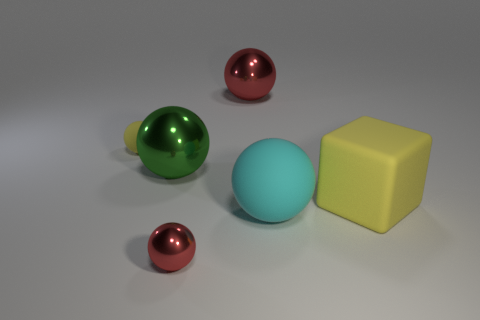The cyan object has what size?
Keep it short and to the point. Large. The big object left of the red sphere in front of the yellow matte thing that is right of the cyan thing is made of what material?
Give a very brief answer. Metal. The big cube that is the same material as the cyan object is what color?
Offer a very short reply. Yellow. How many tiny matte objects are to the right of the yellow object that is in front of the yellow matte object that is to the left of the large yellow rubber block?
Your response must be concise. 0. There is a ball that is the same color as the large block; what material is it?
Offer a very short reply. Rubber. Are there any other things that have the same shape as the large green metal object?
Ensure brevity in your answer.  Yes. How many things are either tiny spheres that are on the right side of the green object or purple metallic balls?
Your response must be concise. 1. Does the big matte object behind the cyan rubber object have the same color as the tiny metallic object?
Offer a terse response. No. The green object in front of the small sphere left of the small red metal sphere is what shape?
Provide a succinct answer. Sphere. Is the number of small yellow matte things on the right side of the big rubber cube less than the number of things that are right of the big red metal sphere?
Ensure brevity in your answer.  Yes. 